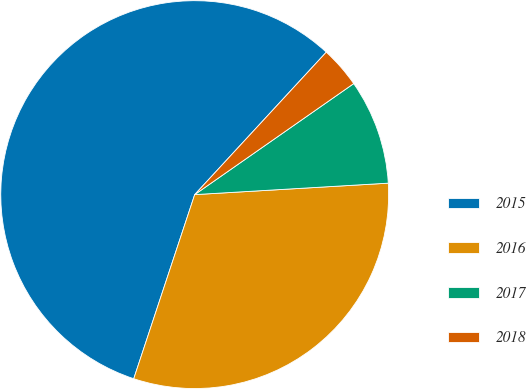Convert chart to OTSL. <chart><loc_0><loc_0><loc_500><loc_500><pie_chart><fcel>2015<fcel>2016<fcel>2017<fcel>2018<nl><fcel>56.78%<fcel>31.03%<fcel>8.76%<fcel>3.43%<nl></chart> 